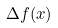Convert formula to latex. <formula><loc_0><loc_0><loc_500><loc_500>\Delta f ( x )</formula> 